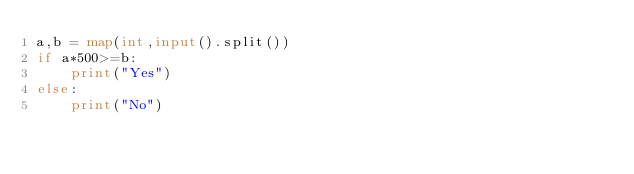Convert code to text. <code><loc_0><loc_0><loc_500><loc_500><_Python_>a,b = map(int,input().split())
if a*500>=b:
    print("Yes")
else:
    print("No")

</code> 